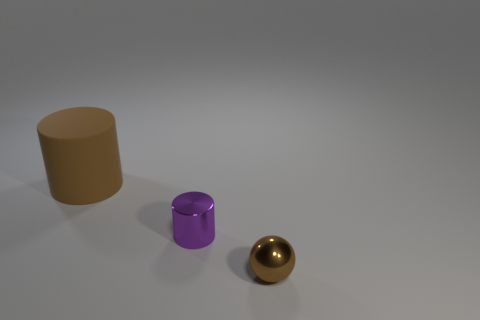Is there any other thing that is the same color as the big thing?
Your response must be concise. Yes. Is the material of the small thing that is on the left side of the tiny brown metallic thing the same as the small sphere?
Offer a terse response. Yes. What number of small things are right of the tiny purple cylinder and on the left side of the ball?
Ensure brevity in your answer.  0. What is the size of the brown thing behind the brown object in front of the large brown object?
Provide a succinct answer. Large. Is there any other thing that is the same material as the small purple thing?
Your answer should be very brief. Yes. Are there more big red metallic blocks than brown matte objects?
Offer a terse response. No. Is the color of the small thing that is right of the tiny purple cylinder the same as the metal thing left of the brown metallic ball?
Your answer should be very brief. No. Is there a big brown rubber thing to the right of the brown object that is on the left side of the brown shiny object?
Ensure brevity in your answer.  No. Is the number of small metal things that are right of the tiny purple metal cylinder less than the number of purple cylinders that are right of the tiny metal sphere?
Your answer should be compact. No. Do the thing in front of the metallic cylinder and the tiny thing that is on the left side of the metal ball have the same material?
Offer a terse response. Yes. 